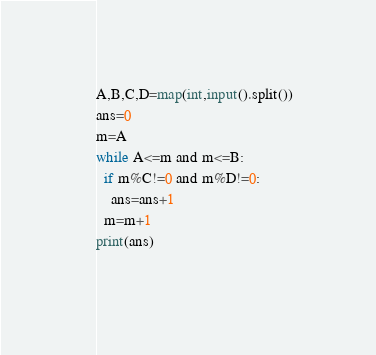Convert code to text. <code><loc_0><loc_0><loc_500><loc_500><_Python_>A,B,C,D=map(int,input().split())
ans=0
m=A
while A<=m and m<=B:
  if m%C!=0 and m%D!=0:
    ans=ans+1
  m=m+1
print(ans)  
  </code> 